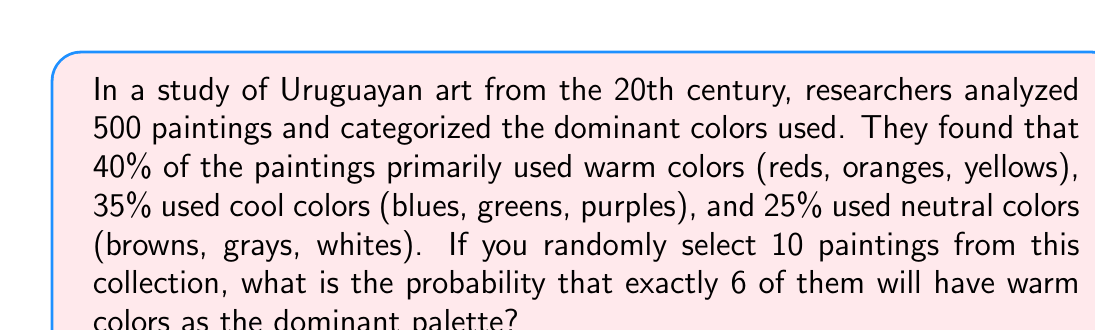Can you answer this question? To solve this problem, we need to use the binomial probability distribution, as we are dealing with a fixed number of independent trials (selecting 10 paintings) with two possible outcomes for each trial (warm color or not warm color).

The probability mass function for the binomial distribution is:

$$P(X = k) = \binom{n}{k} p^k (1-p)^{n-k}$$

Where:
$n$ = number of trials (10 paintings)
$k$ = number of successes (6 warm color paintings)
$p$ = probability of success on each trial (0.40 for warm colors)

Step 1: Calculate the binomial coefficient
$$\binom{10}{6} = \frac{10!}{6!(10-6)!} = \frac{10!}{6!4!} = 210$$

Step 2: Calculate $p^k$
$$(0.40)^6 = 0.004096$$

Step 3: Calculate $(1-p)^{n-k}$
$$(1-0.40)^{10-6} = (0.60)^4 = 0.1296$$

Step 4: Multiply all parts together
$$210 \times 0.004096 \times 0.1296 = 0.1115$$

Therefore, the probability of selecting exactly 6 warm color paintings out of 10 randomly chosen paintings is approximately 0.1115 or 11.15%.
Answer: 0.1115 